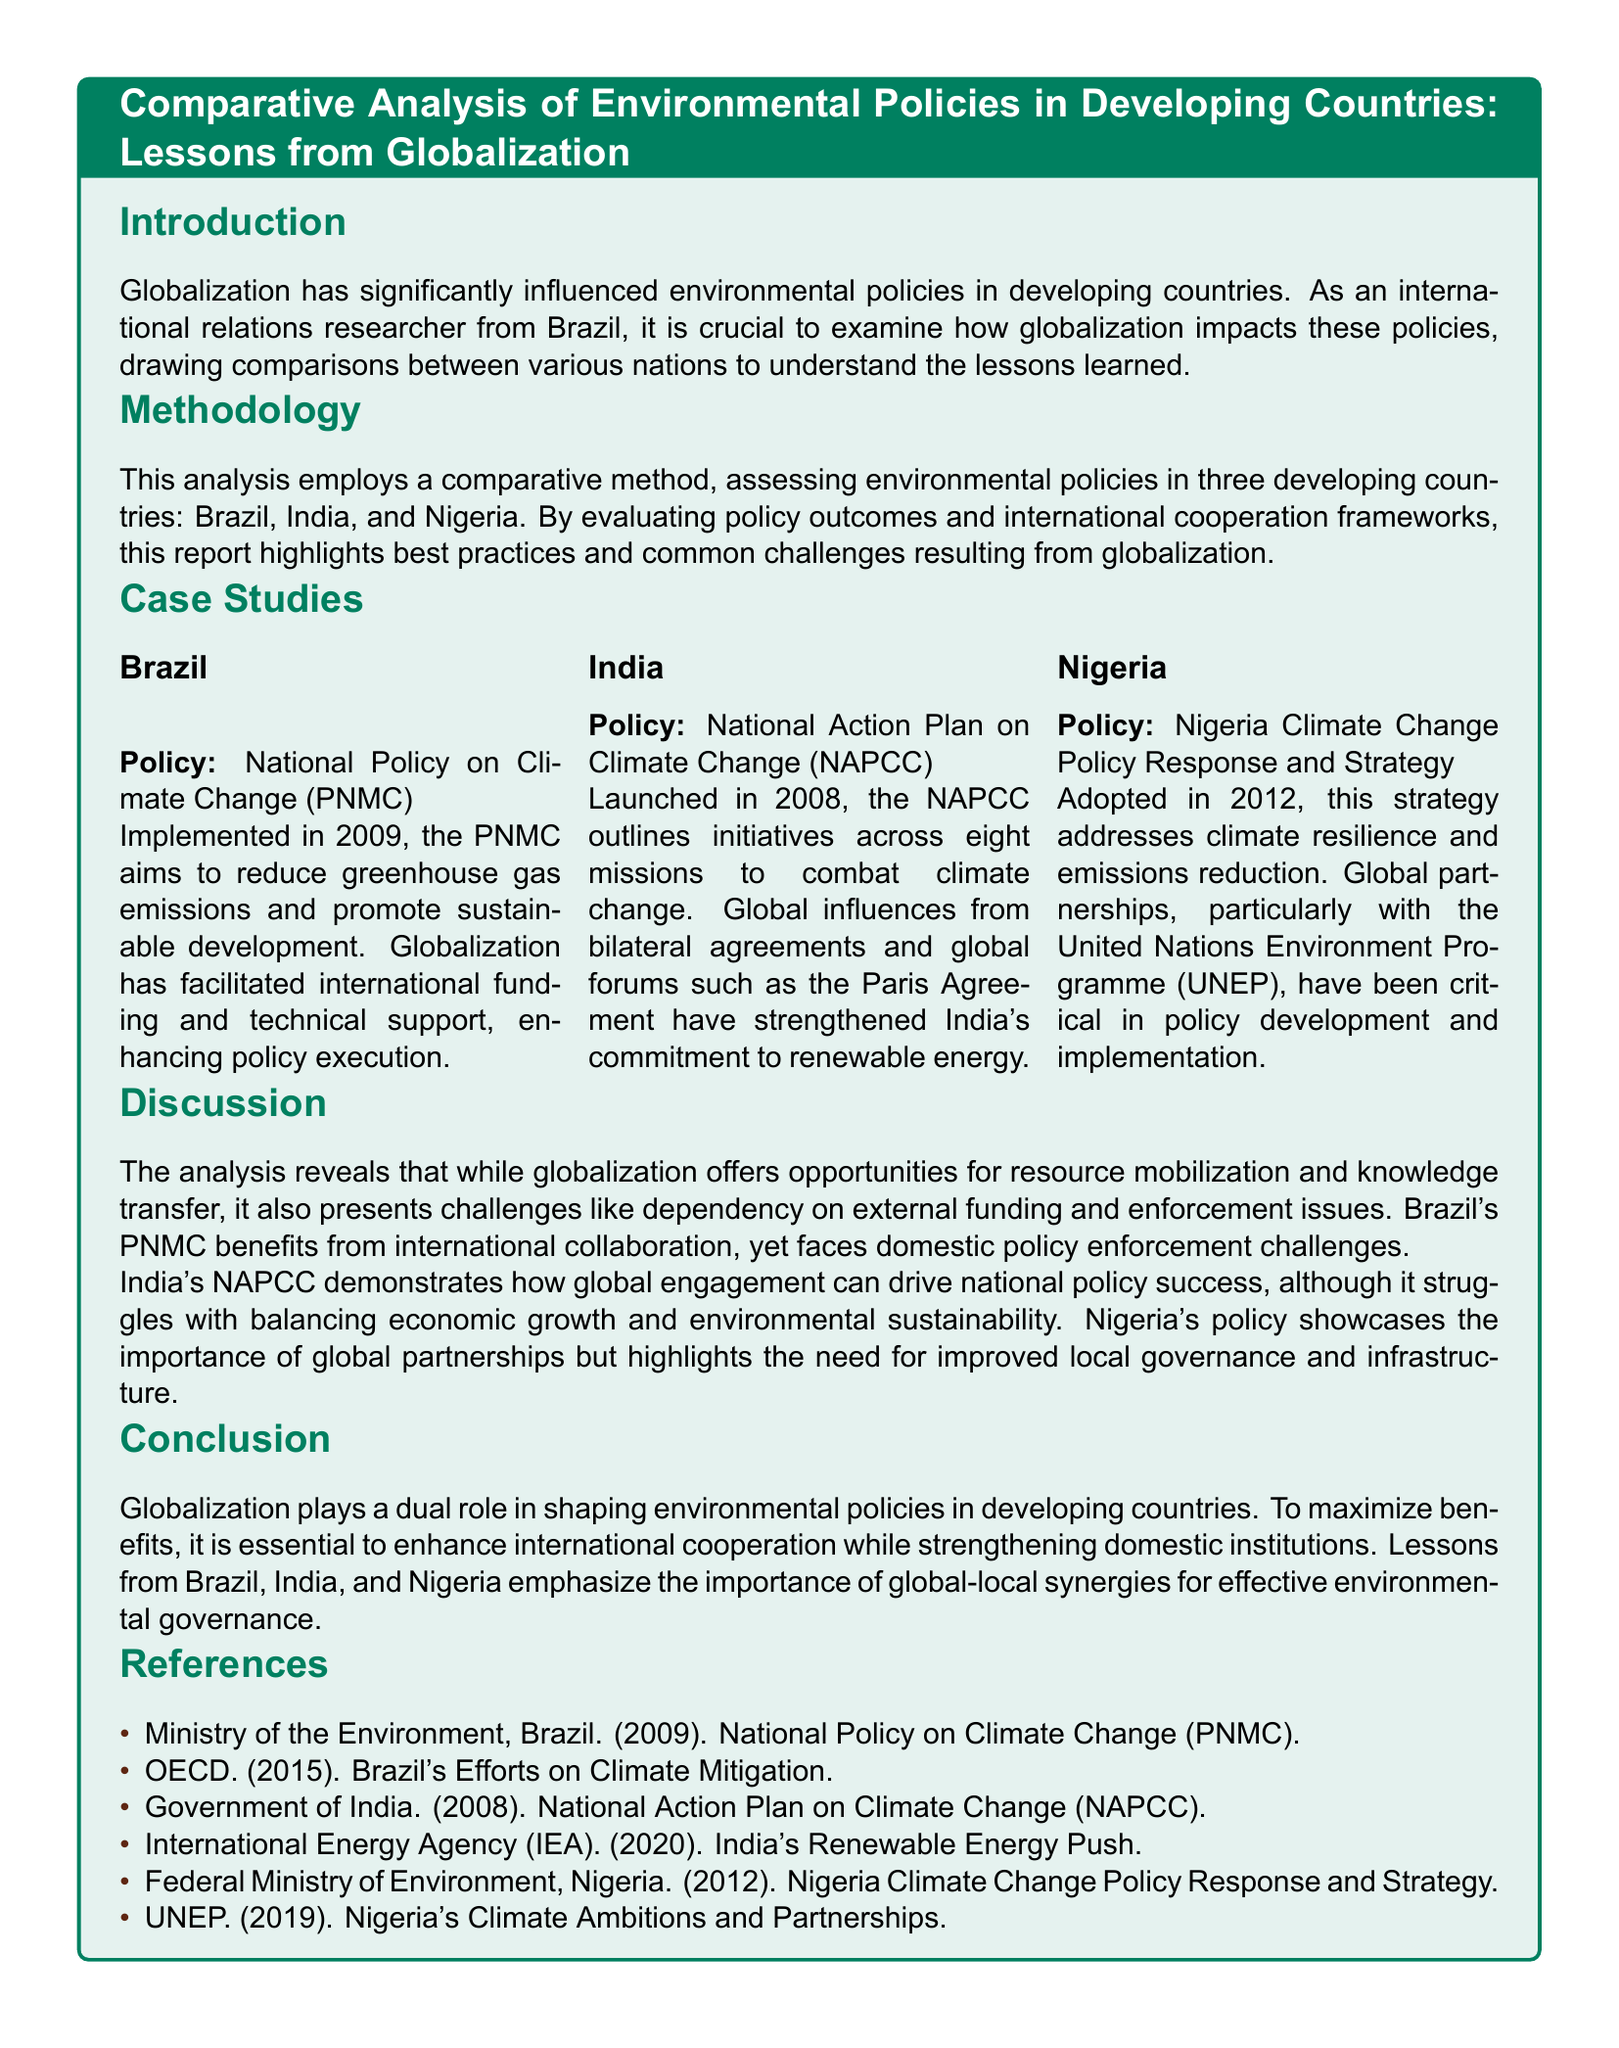What is the title of the report? The title is presented in a prominent manner at the beginning of the document, showcasing the main focus of the analysis.
Answer: Comparative Analysis of Environmental Policies in Developing Countries: Lessons from Globalization Which three countries are analyzed in the report? The document lists Brazil, India, and Nigeria as the countries selected for the comparative analysis of their environmental policies.
Answer: Brazil, India, Nigeria When was Brazil’s National Policy on Climate Change implemented? The document provides a specific year when Brazil's policy was put into action, which is essential for understanding its timeline.
Answer: 2009 What is the aim of India's National Action Plan on Climate Change? The report outlines the main objective of India's policy, highlighting its focus and initiatives in addressing climate issues.
Answer: Combat climate change Which organization partnered with Nigeria in policy development? The document mentions a specific global organization that played a crucial role in Nigeria's environmental policy strategies.
Answer: United Nations Environment Programme (UNEP) What are the common challenges faced by developing countries due to globalization? The discussion section identifies specific issues that arise as a result of globalization, pertinent to environmental policy implementation in these nations.
Answer: Dependency on external funding and enforcement issues In what year was Nigeria’s Climate Change Policy Response and Strategy adopted? The information highlights a critical date related to Nigeria's policy that assists in analyzing its context.
Answer: 2012 What does the analysis suggest is essential for maximizing the benefits of globalization? The conclusion emphasizes a key requirement for developing countries to benefit from globalization in their policy frameworks.
Answer: Enhance international cooperation What does the report recommend for effective environmental governance? This question summarizes the report's final takeaway regarding what should be strengthened for improved governance in environmental policy.
Answer: Global-local synergies 